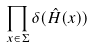Convert formula to latex. <formula><loc_0><loc_0><loc_500><loc_500>\prod _ { x \in \Sigma } \delta ( \hat { H } ( x ) )</formula> 